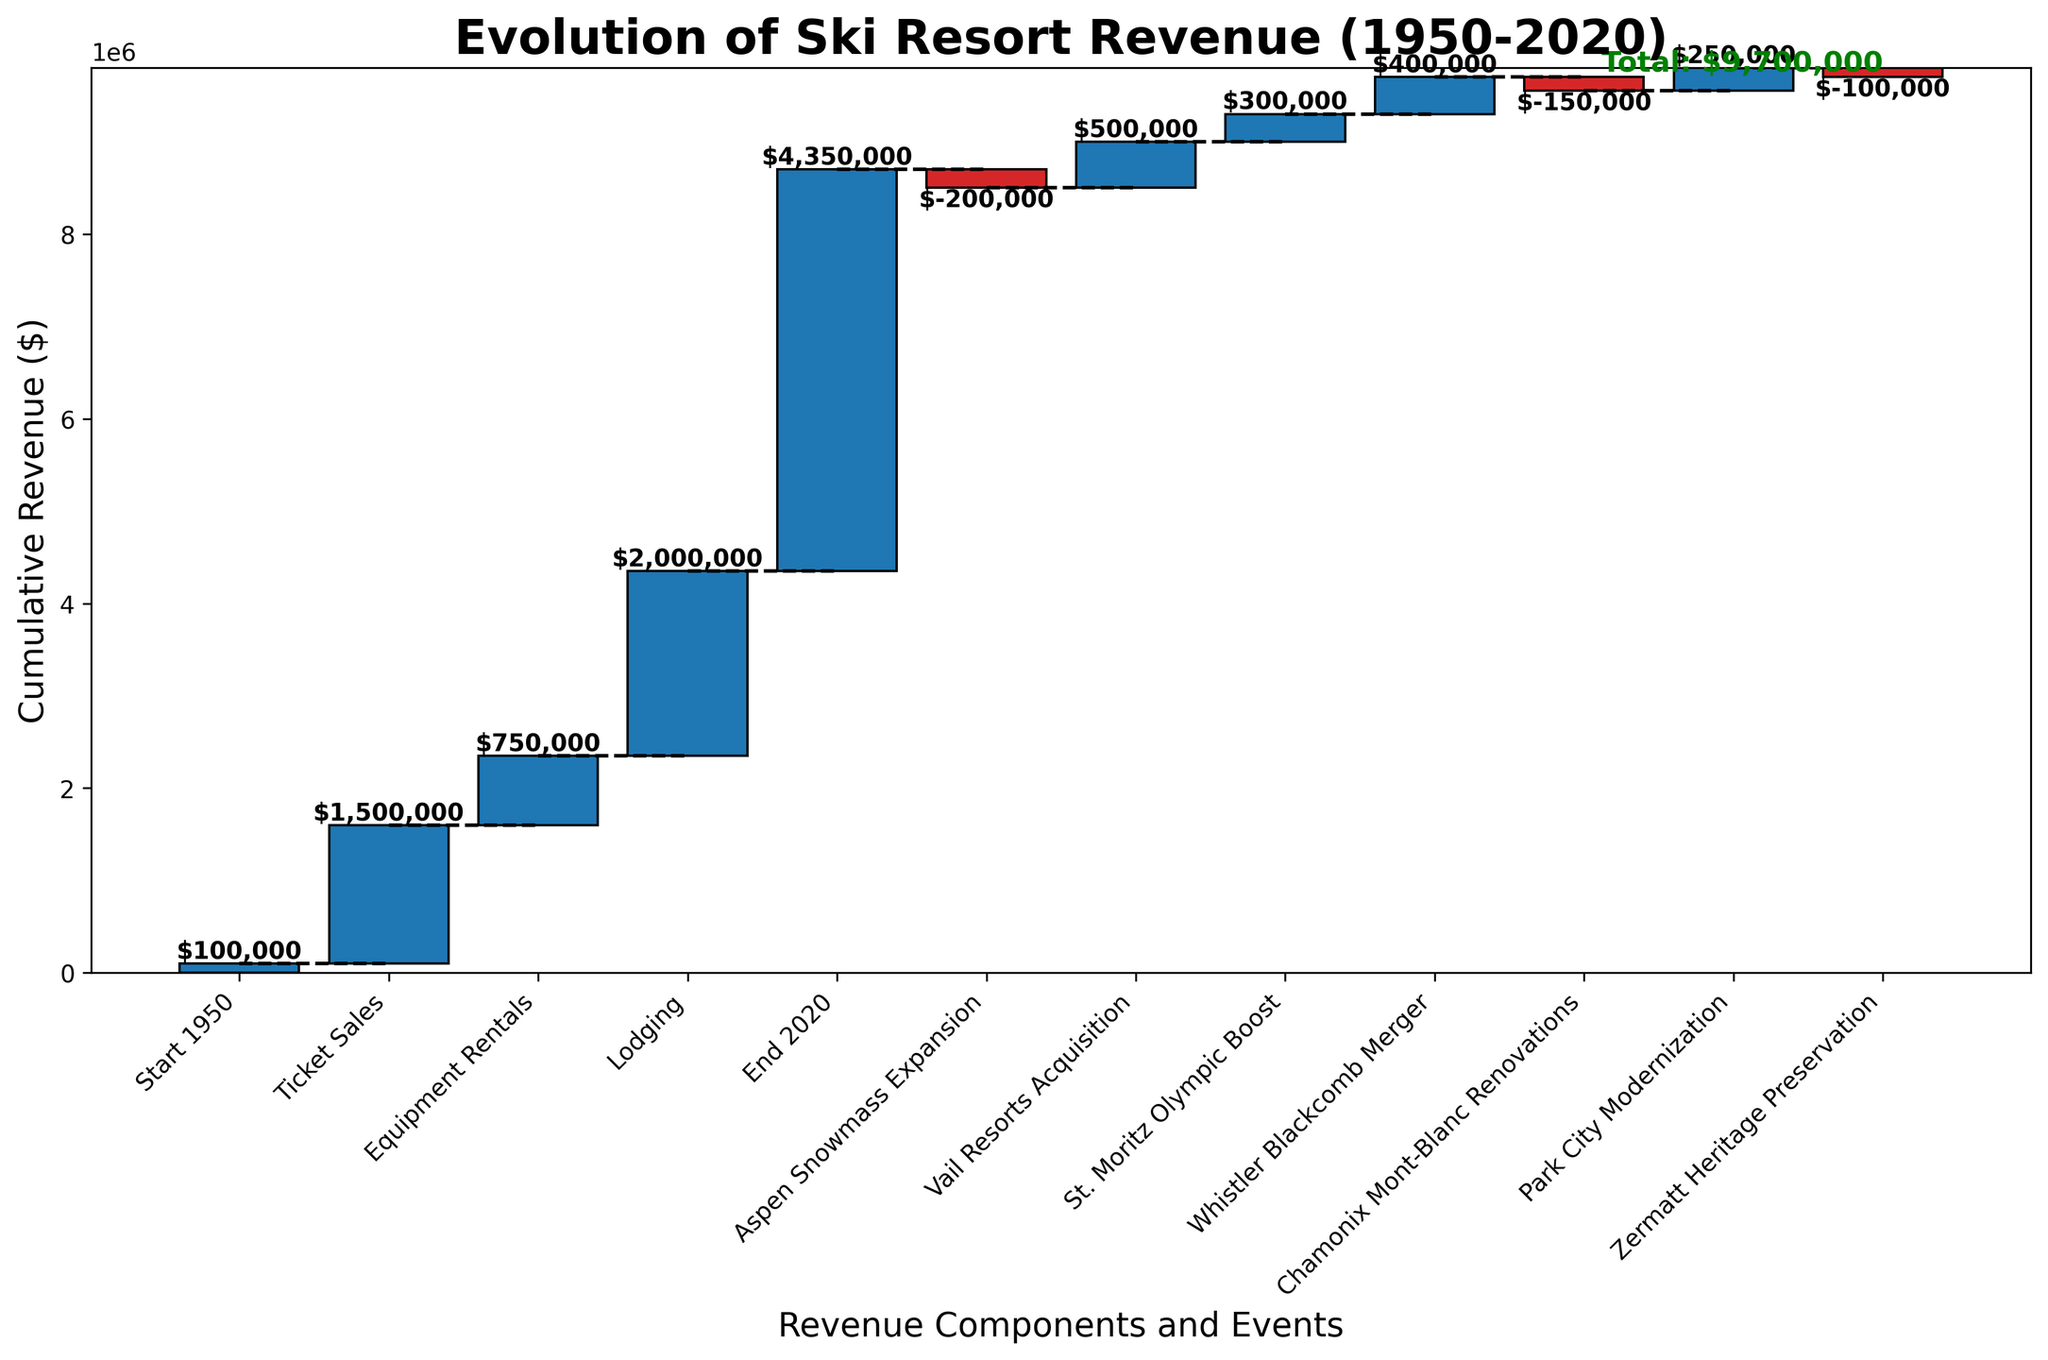What is the title of the chart? The title is shown at the top of the chart. It reads "Evolution of Ski Resort Revenue (1950-2020)."
Answer: Evolution of Ski Resort Revenue (1950-2020) What are the categories listed on the x-axis? The categories are displayed on the x-axis of the chart. They include "Start 1950," "Ticket Sales," "Equipment Rentals," "Lodging," "Aspen Snowmass Expansion," "Vail Resorts Acquisition," "St. Moritz Olympic Boost," "Whistler Blackcomb Merger," "Chamonix Mont-Blanc Renovations," "Park City Modernization," "Zermatt Heritage Preservation," and "End 2020."
Answer: Start 1950, Ticket Sales, Equipment Rentals, Lodging, Aspen Snowmass Expansion, Vail Resorts Acquisition, St. Moritz Olympic Boost, Whistler Blackcomb Merger, Chamonix Mont-Blanc Renovations, Park City Modernization, Zermatt Heritage Preservation, End 2020 What is the cumulative revenue at the end of 2020? The cumulative revenue at the end of 2020 is given as the total value at the "End 2020" category. This value is indicated on the chart.
Answer: $4,350,000 Which event had the most negative impact on revenue? By observing the bars, the event with the most negative impact will have the longest red bar. From the chart, "Aspen Snowmass Expansion" shows the largest negative decrease.
Answer: Aspen Snowmass Expansion How did the "Lodging" category affect the cumulative revenue? The "Lodging" category had a positive impact on cumulative revenue, represented by a bar that increased the cumulative total. The value added is $2,000,000.
Answer: Increased by $2,000,000 What was the net impact of events "Aspen Snowmass Expansion" and "Chamonix Mont-Blanc Renovations"? To find the net impact, sum the values of "Aspen Snowmass Expansion" and "Chamonix Mont-Blanc Renovations," both of which are negative. -200,000 + (-150,000) results in a net impact of -350,000.
Answer: -350,000 Compare the value added by "Whistler Blackcomb Merger" with "Park City Modernization." Which was greater? The values added by both events are given. "Whistler Blackcomb Merger" added $400,000, while "Park City Modernization" added $250,000. 400,000 is greater than 250,000.
Answer: Whistler Blackcomb Merger What is the total revenue increase from the three primary revenue sources: Ticket Sales, Equipment Rentals, and Lodging? Sum the values of "Ticket Sales," "Equipment Rentals," and "Lodging": 1,500,000 + 750,000 + 2,000,000 equals 4,250,000.
Answer: $4,250,000 What is the impact of the "St. Moritz Olympic Boost" on the overall revenue? The "St. Moritz Olympic Boost" had a positive impact, shown by the increase in the cumulative revenue bar. The specific impact is $300,000.
Answer: Increased by $300,000 Calculate the percentage increase in revenue from 1950 to 2020. Take the final cumulative revenue at "End 2020" ($4,350,000) and subtract the "Start 1950" value ($100,000), then divide by the "Start 1950" value and multiply by 100. (4,350,000 - 100,000) / 100,000 * 100 = 4250%.
Answer: 4250% 